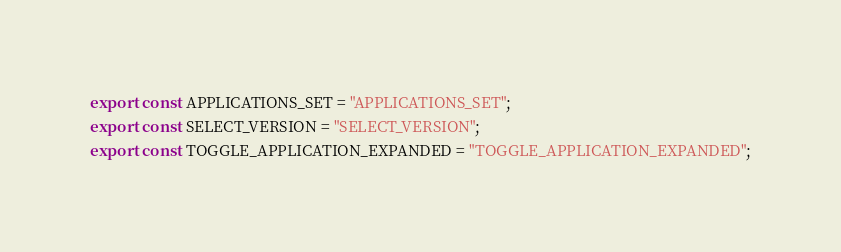Convert code to text. <code><loc_0><loc_0><loc_500><loc_500><_JavaScript_>export const APPLICATIONS_SET = "APPLICATIONS_SET";
export const SELECT_VERSION = "SELECT_VERSION";
export const TOGGLE_APPLICATION_EXPANDED = "TOGGLE_APPLICATION_EXPANDED";
</code> 